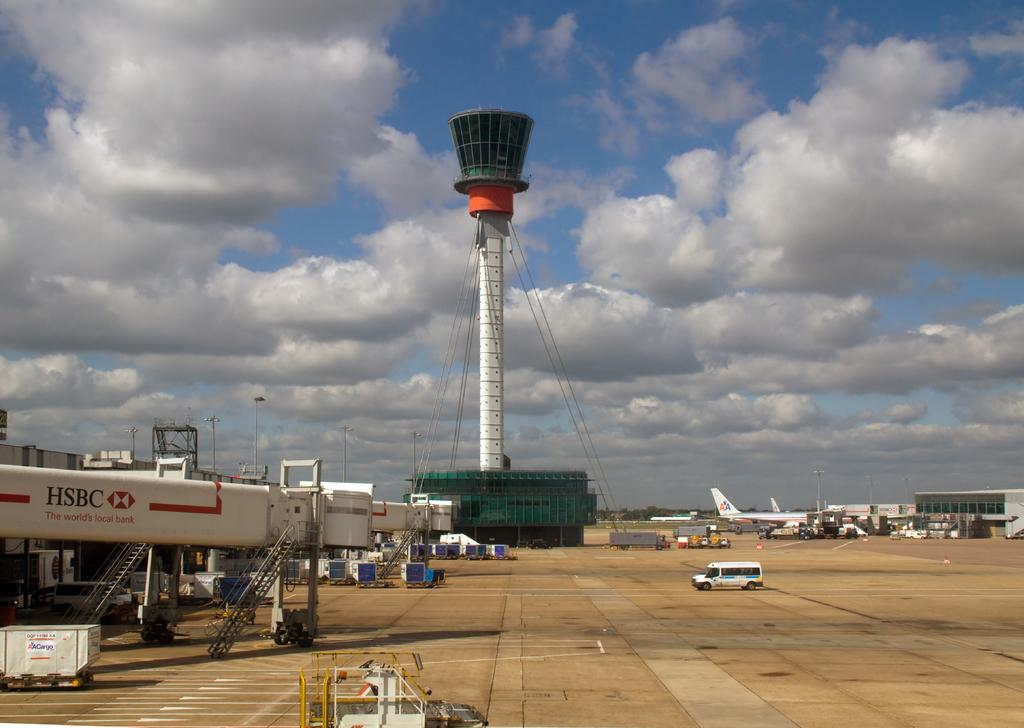<image>
Offer a succinct explanation of the picture presented. HSBC bank advertises on machinery at the airport. 